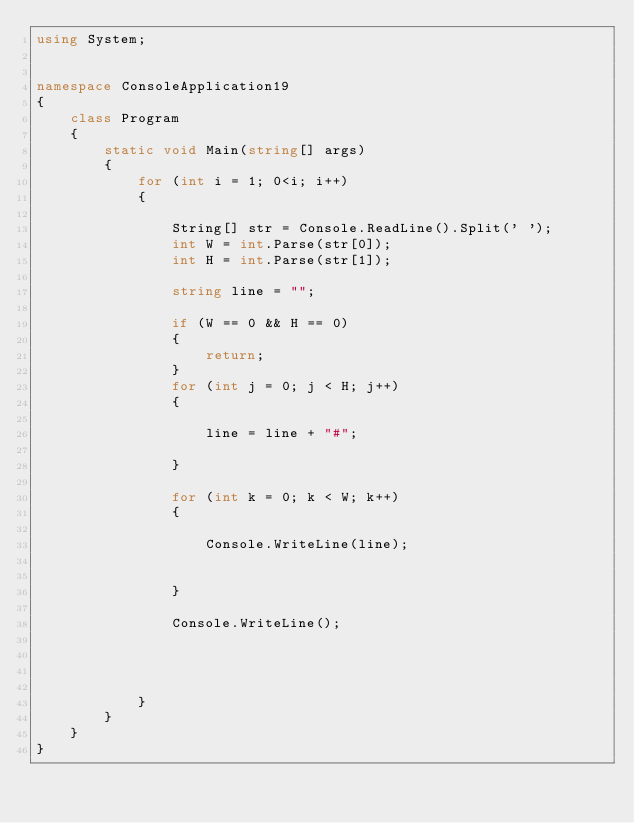Convert code to text. <code><loc_0><loc_0><loc_500><loc_500><_C#_>using System;


namespace ConsoleApplication19
{
    class Program
    {
        static void Main(string[] args)
        {
            for (int i = 1; 0<i; i++)
            {

                String[] str = Console.ReadLine().Split(' ');
                int W = int.Parse(str[0]);
                int H = int.Parse(str[1]);
                
                string line = "";

                if (W == 0 && H == 0)
                {
                    return;
                }
                for (int j = 0; j < H; j++)
                {

                    line = line + "#";

                }

                for (int k = 0; k < W; k++)
                {

                    Console.WriteLine(line);


                }

                Console.WriteLine();

                


            }
        }
    }
}</code> 